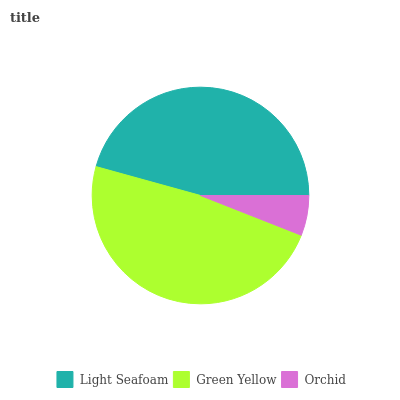Is Orchid the minimum?
Answer yes or no. Yes. Is Green Yellow the maximum?
Answer yes or no. Yes. Is Green Yellow the minimum?
Answer yes or no. No. Is Orchid the maximum?
Answer yes or no. No. Is Green Yellow greater than Orchid?
Answer yes or no. Yes. Is Orchid less than Green Yellow?
Answer yes or no. Yes. Is Orchid greater than Green Yellow?
Answer yes or no. No. Is Green Yellow less than Orchid?
Answer yes or no. No. Is Light Seafoam the high median?
Answer yes or no. Yes. Is Light Seafoam the low median?
Answer yes or no. Yes. Is Green Yellow the high median?
Answer yes or no. No. Is Green Yellow the low median?
Answer yes or no. No. 